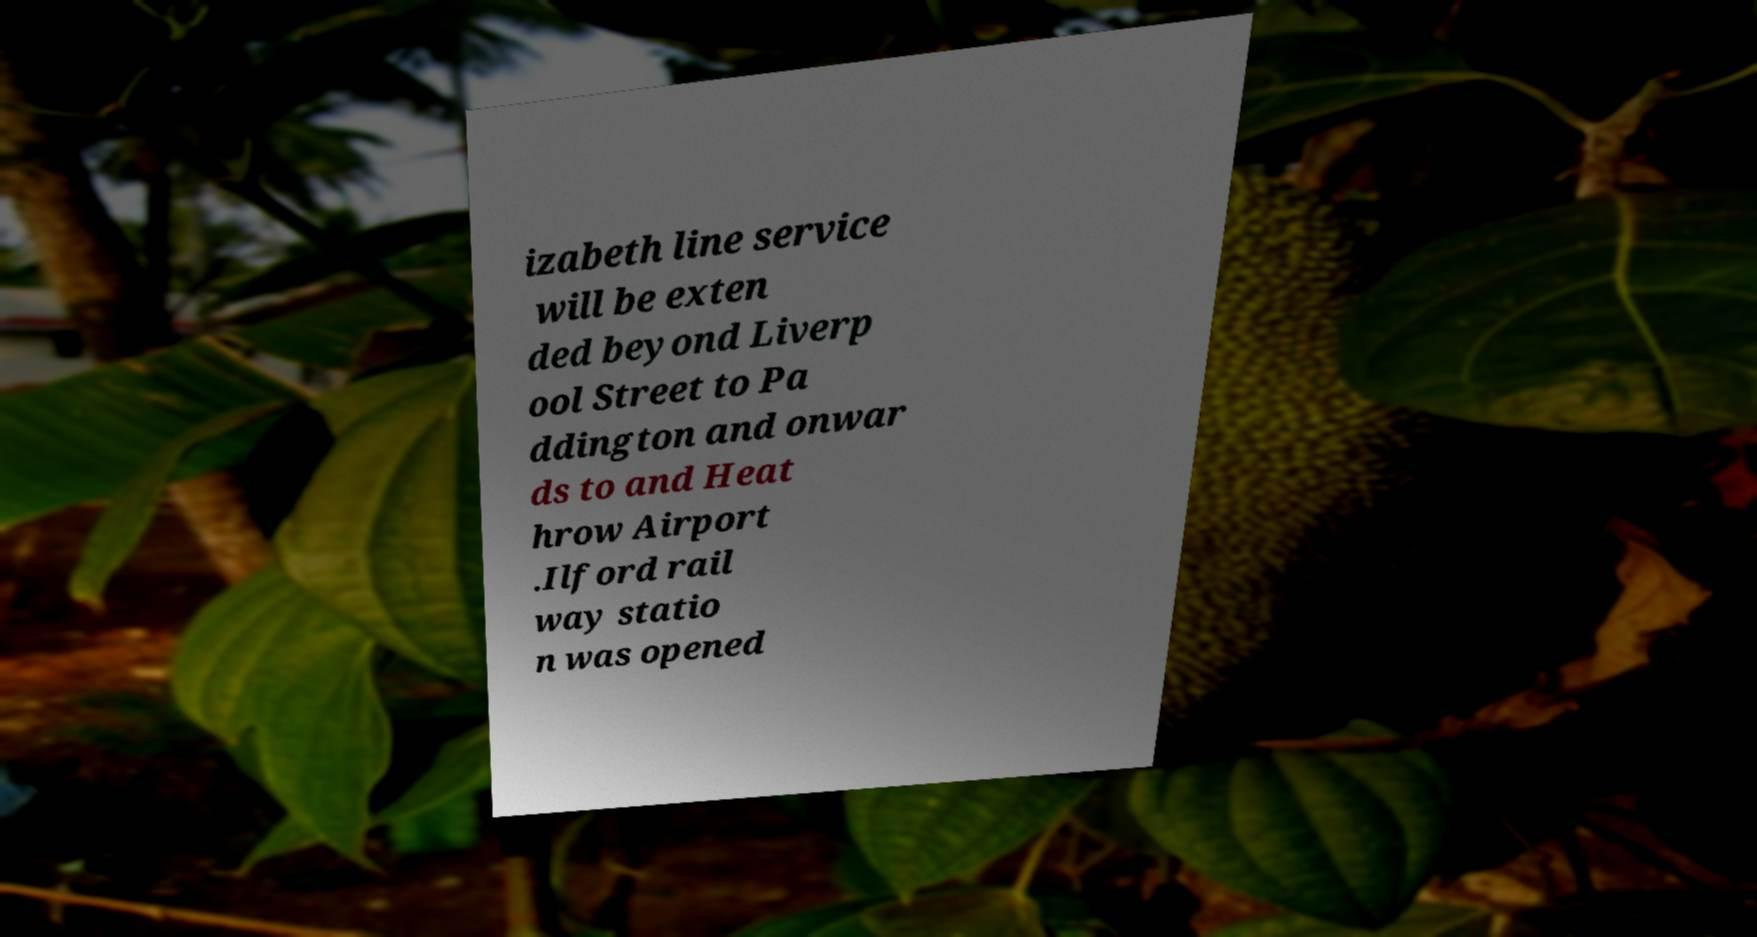Can you accurately transcribe the text from the provided image for me? izabeth line service will be exten ded beyond Liverp ool Street to Pa ddington and onwar ds to and Heat hrow Airport .Ilford rail way statio n was opened 